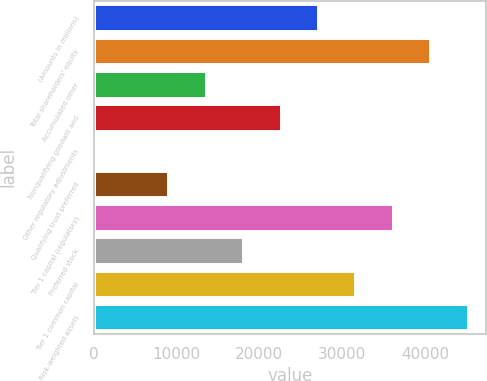<chart> <loc_0><loc_0><loc_500><loc_500><bar_chart><fcel>(Amounts in millions)<fcel>Total shareholders' equity<fcel>Accumulated other<fcel>Nonqualifying goodwill and<fcel>Other regulatory adjustments<fcel>Qualifying trust preferred<fcel>Tier 1 capital (regulatory)<fcel>Preferred stock<fcel>Tier 1 common capital<fcel>Risk-weighted assets<nl><fcel>27090<fcel>40632<fcel>13548<fcel>22576<fcel>6<fcel>9034<fcel>36118<fcel>18062<fcel>31604<fcel>45146<nl></chart> 